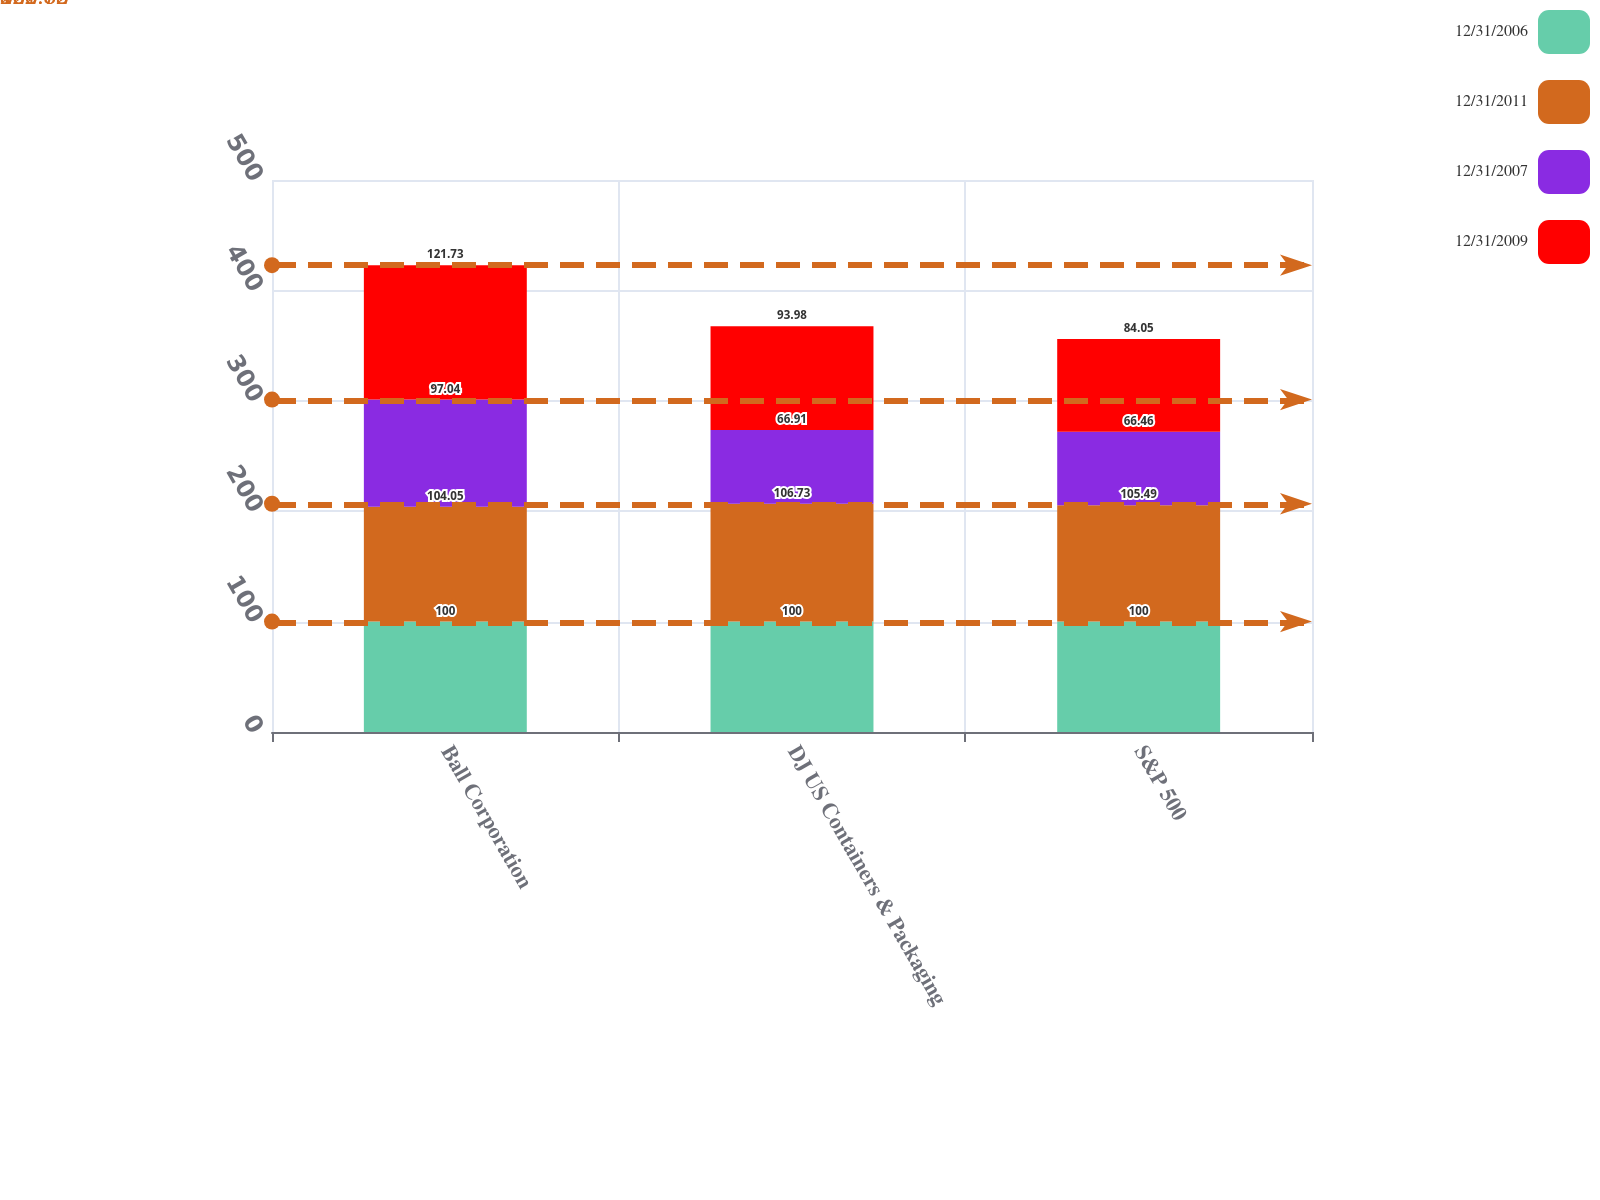Convert chart. <chart><loc_0><loc_0><loc_500><loc_500><stacked_bar_chart><ecel><fcel>Ball Corporation<fcel>DJ US Containers & Packaging<fcel>S&P 500<nl><fcel>12/31/2006<fcel>100<fcel>100<fcel>100<nl><fcel>12/31/2011<fcel>104.05<fcel>106.73<fcel>105.49<nl><fcel>12/31/2007<fcel>97.04<fcel>66.91<fcel>66.46<nl><fcel>12/31/2009<fcel>121.73<fcel>93.98<fcel>84.05<nl></chart> 